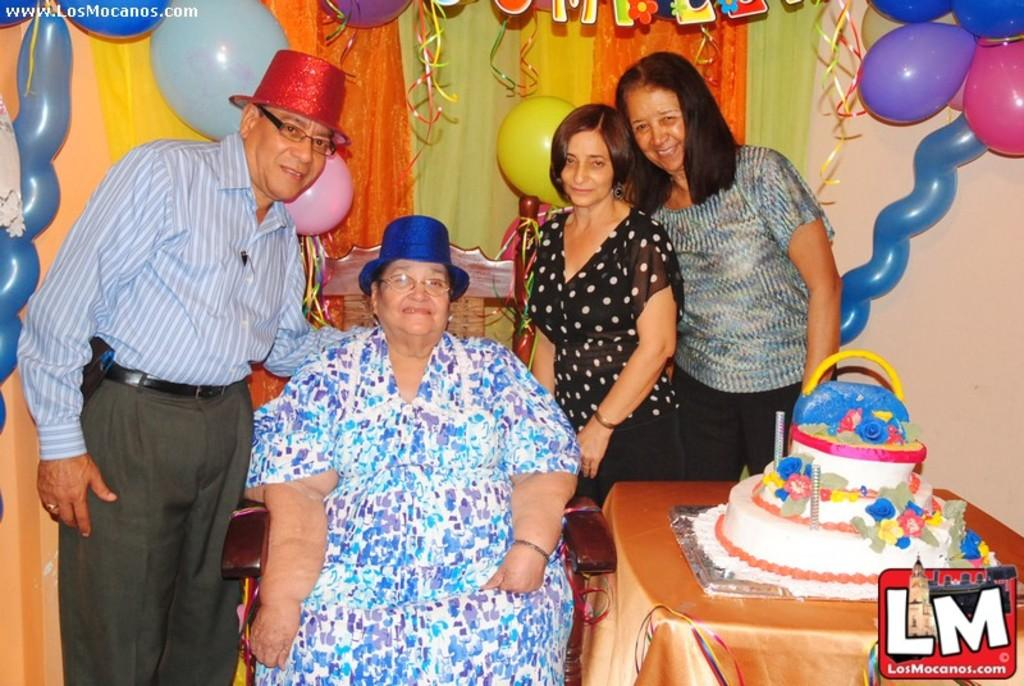What are the persons in the image doing? The persons in the image are sitting on chairs and standing on the floor. What is on the table in the image? There is a cake on a table in the image. What can be seen on the curtain in the background of the image? There are decorations on the curtain in the background of the image. What can be seen on the wall in the background of the image? There are decorations on the wall in the background of the image. What type of badge is being awarded to the person with the most wealth in the image? There is no indication of wealth or any awards being given in the image; it simply shows persons sitting and standing with a cake on a table and decorations in the background. 